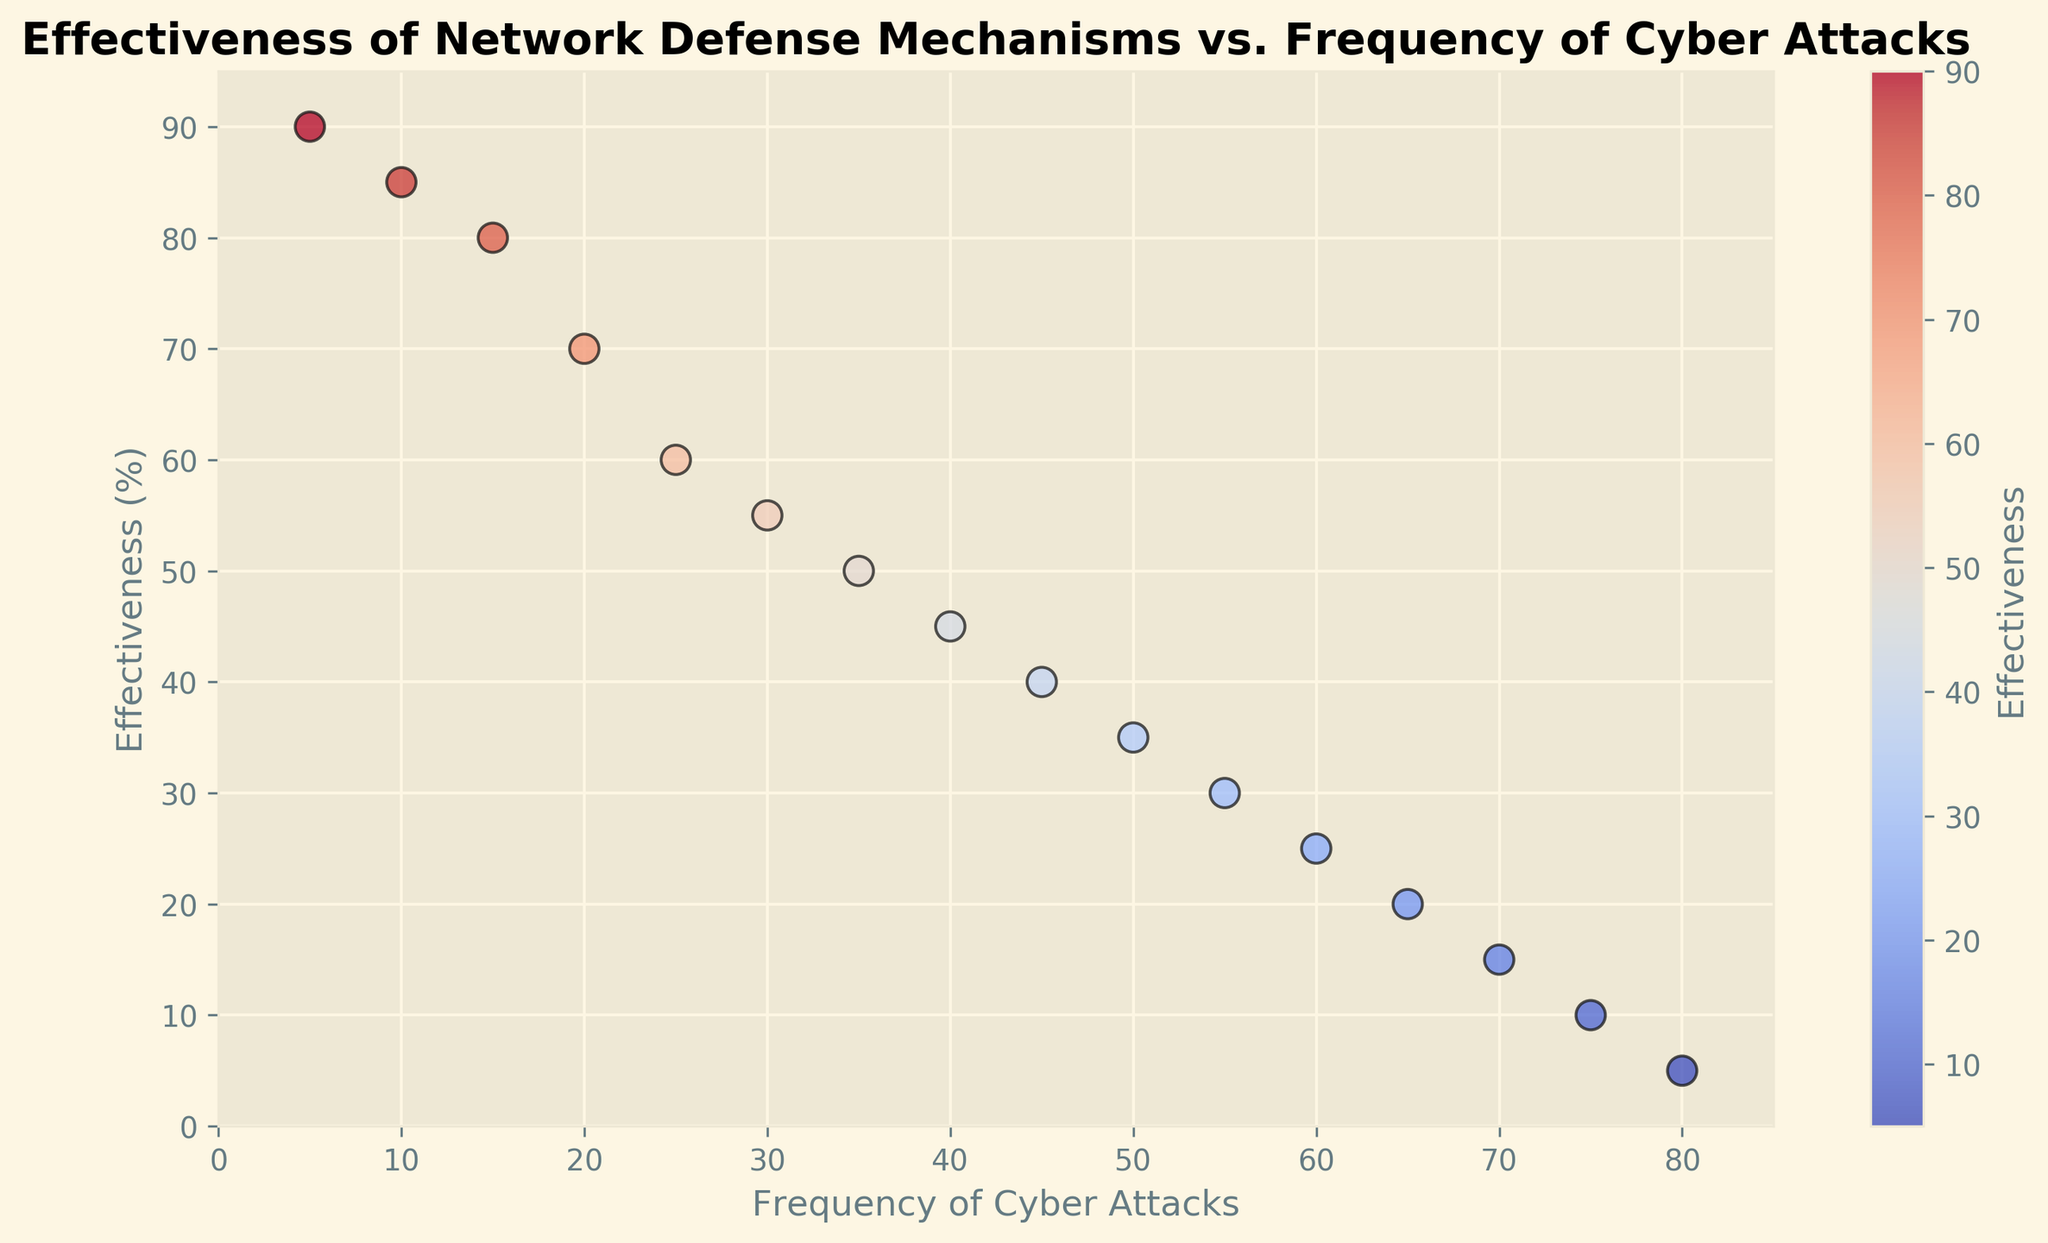What's the general trend between effectiveness and frequency of cyber attacks in the plot? The scatter plot shows that as the frequency of cyber attacks increases, the effectiveness of network defense mechanisms generally decreases. This is evident because the points descend from left to right.
Answer: Decreasing trend Which data point shows the highest effectiveness? The highest effectiveness point is the one at the top of the scatter plot, which corresponds to an effectiveness of 90%.
Answer: 90% What is the frequency of cyber attacks when the effectiveness is 50%? Locate the point on the plot where the vertical axis intersects the effectiveness of 50%. The frequency of cyber attacks at this point is 35.
Answer: 35 How does the color of the points relate to the effectiveness? The color of the points represents the effectiveness, ranging from cooler to warmer colors (based on the color bar), with cooler colors indicating lower effectiveness and warmer colors indicating higher effectiveness.
Answer: Warmer colors indicate higher effectiveness What is the difference in effectiveness between the points where frequency of cyber attacks is 25 and 65? Identify the effectiveness values at frequencies 25 and 65 from the plot, which are 60% and 20%, respectively. The difference is 60% - 20% = 40%.
Answer: 40% What frequency of cyber attacks corresponds to the lowest effectiveness? The lowest effectiveness is observed at the bottom of the plot, which is 5%. The corresponding frequency of cyber attacks is 80.
Answer: 80 What is the average effectiveness of the points where the frequency of cyber attacks is between 45 and 55? Identify the effectiveness values within this range from the plot (45, 40, 35, and 30). The average is calculated as (40 + 35 + 30) / 3 = 35%.
Answer: 35% Are there any points where the frequency of cyber attacks is the same but effectiveness is different? By examining the scatter plot, no two points share the same frequency of cyber attacks with different effectiveness, indicating a unique pair of values for each point.
Answer: No Which color from the color bar corresponds to an effectiveness of about 75%? Refer to the color bar on the scatter plot where the effectiveness is around 75%. The corresponding color is toward the warmer end but not the warmest (reddish).
Answer: Reddish Is there a point where the frequency of cyber attacks is less than 20 and effectiveness is greater than 80%? Check the plot for points where the frequency of cyber attacks is below 20 and effectiveness is above 80%. There is one such point at (5, 90) and another at (10, 85).
Answer: Yes 